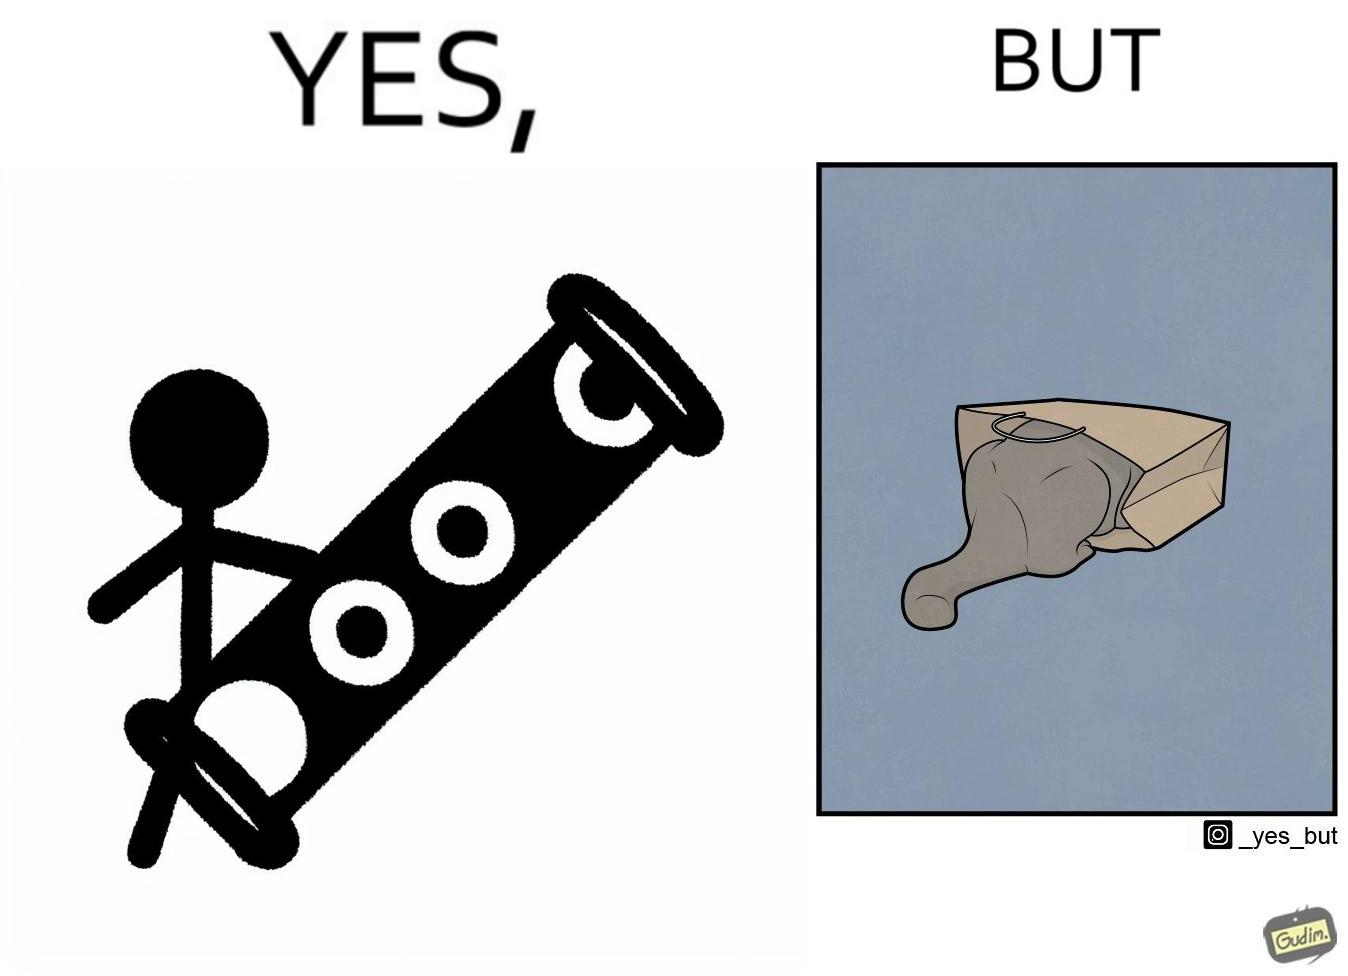What is shown in the left half versus the right half of this image? In the left part of the image: a long piece of cylinder with two circular holes over its surface and two holes at top and bottom and a hanging toy at one end In the right part of the image: an animal hiding its face in a paper bag, probably a cat or dog 